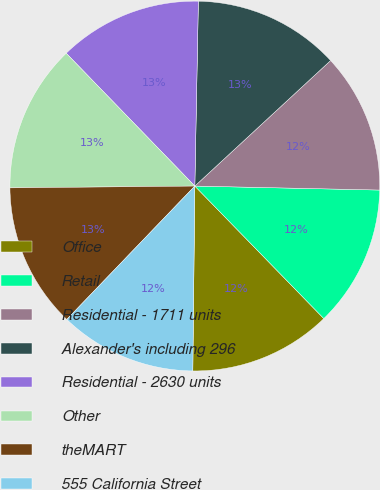Convert chart to OTSL. <chart><loc_0><loc_0><loc_500><loc_500><pie_chart><fcel>Office<fcel>Retail<fcel>Residential - 1711 units<fcel>Alexander's including 296<fcel>Residential - 2630 units<fcel>Other<fcel>theMART<fcel>555 California Street<nl><fcel>12.46%<fcel>12.37%<fcel>12.22%<fcel>12.82%<fcel>12.55%<fcel>12.91%<fcel>12.67%<fcel>12.0%<nl></chart> 